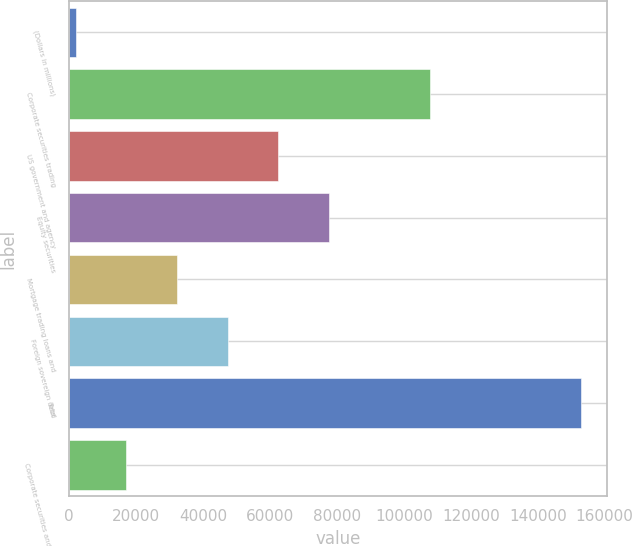Convert chart to OTSL. <chart><loc_0><loc_0><loc_500><loc_500><bar_chart><fcel>(Dollars in millions)<fcel>Corporate securities trading<fcel>US government and agency<fcel>Equity securities<fcel>Mortgage trading loans and<fcel>Foreign sovereign debt<fcel>Total<fcel>Corporate securities and other<nl><fcel>2006<fcel>107738<fcel>62424.4<fcel>77529<fcel>32215.2<fcel>47319.8<fcel>153052<fcel>17110.6<nl></chart> 